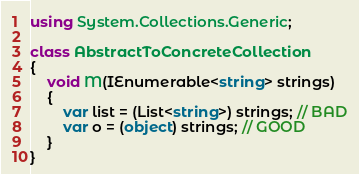<code> <loc_0><loc_0><loc_500><loc_500><_C#_>using System.Collections.Generic;

class AbstractToConcreteCollection
{
    void M(IEnumerable<string> strings)
    {
        var list = (List<string>) strings; // BAD
        var o = (object) strings; // GOOD
    }
}
</code> 